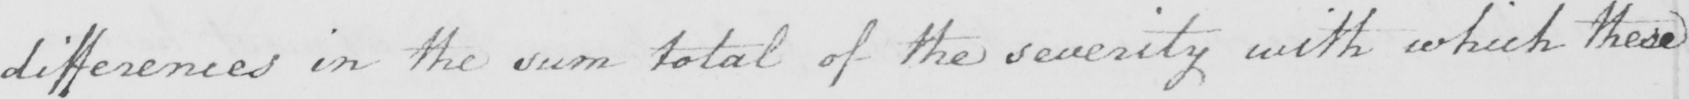Can you read and transcribe this handwriting? differences in the sum total of the severity with which these 